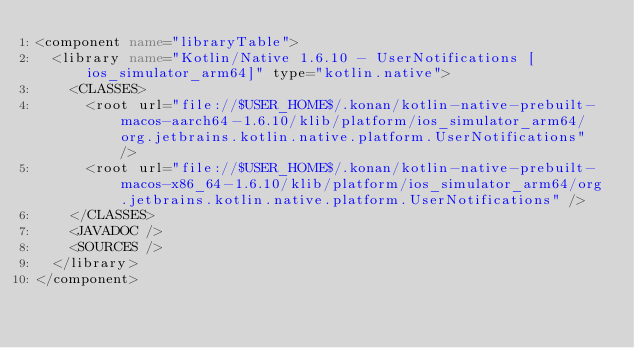<code> <loc_0><loc_0><loc_500><loc_500><_XML_><component name="libraryTable">
  <library name="Kotlin/Native 1.6.10 - UserNotifications [ios_simulator_arm64]" type="kotlin.native">
    <CLASSES>
      <root url="file://$USER_HOME$/.konan/kotlin-native-prebuilt-macos-aarch64-1.6.10/klib/platform/ios_simulator_arm64/org.jetbrains.kotlin.native.platform.UserNotifications" />
      <root url="file://$USER_HOME$/.konan/kotlin-native-prebuilt-macos-x86_64-1.6.10/klib/platform/ios_simulator_arm64/org.jetbrains.kotlin.native.platform.UserNotifications" />
    </CLASSES>
    <JAVADOC />
    <SOURCES />
  </library>
</component></code> 